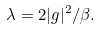<formula> <loc_0><loc_0><loc_500><loc_500>\lambda = 2 | g | ^ { 2 } / \beta .</formula> 